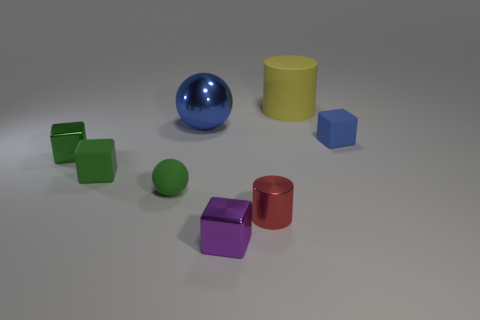Subtract all small green matte cubes. How many cubes are left? 3 Subtract all yellow balls. How many green cubes are left? 2 Subtract all purple blocks. How many blocks are left? 3 Add 1 large rubber cylinders. How many objects exist? 9 Subtract all red blocks. Subtract all brown cylinders. How many blocks are left? 4 Add 2 tiny matte spheres. How many tiny matte spheres are left? 3 Add 3 big blue metallic spheres. How many big blue metallic spheres exist? 4 Subtract 1 red cylinders. How many objects are left? 7 Subtract all small purple blocks. Subtract all metallic spheres. How many objects are left? 6 